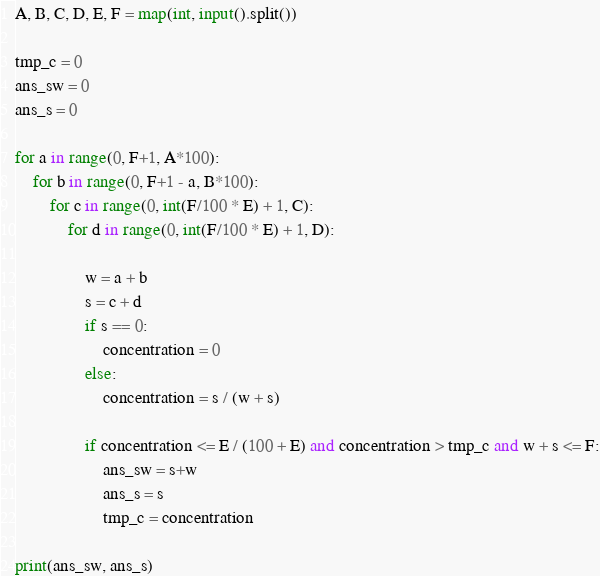Convert code to text. <code><loc_0><loc_0><loc_500><loc_500><_Python_>A, B, C, D, E, F = map(int, input().split())

tmp_c = 0
ans_sw = 0
ans_s = 0

for a in range(0, F+1, A*100):
    for b in range(0, F+1 - a, B*100):
        for c in range(0, int(F/100 * E) + 1, C):
            for d in range(0, int(F/100 * E) + 1, D):

                w = a + b
                s = c + d
                if s == 0:
                    concentration = 0
                else:
                    concentration = s / (w + s)
                    
                if concentration <= E / (100 + E) and concentration > tmp_c and w + s <= F:
                    ans_sw = s+w
                    ans_s = s
                    tmp_c = concentration

print(ans_sw, ans_s)                
</code> 